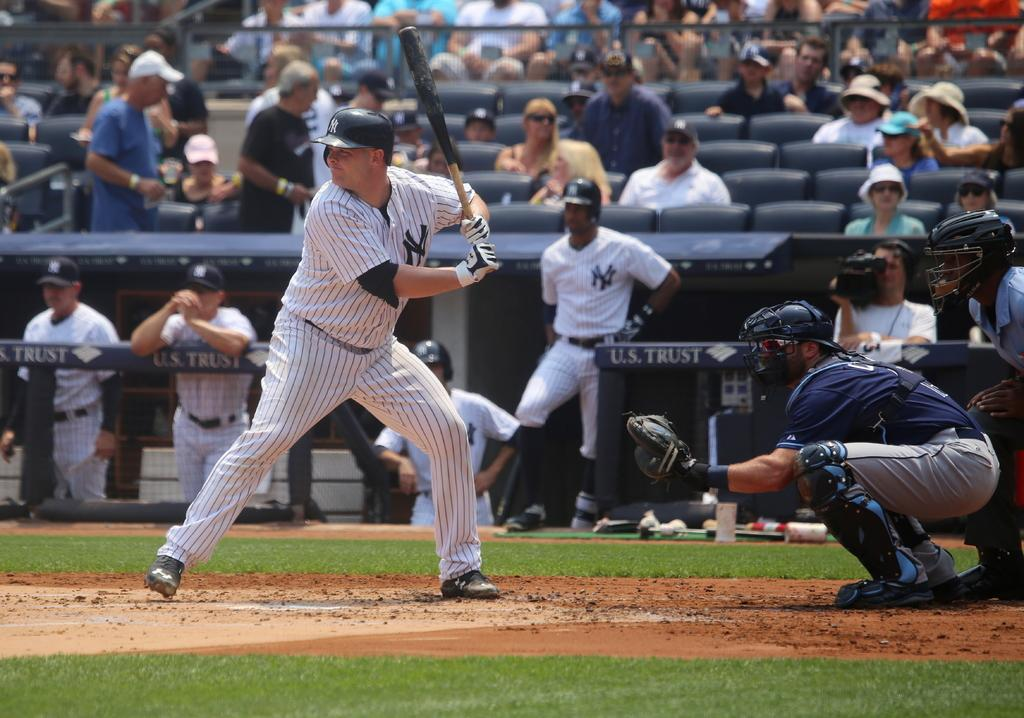<image>
Summarize the visual content of the image. A Yankee's players squares up at home plate. 